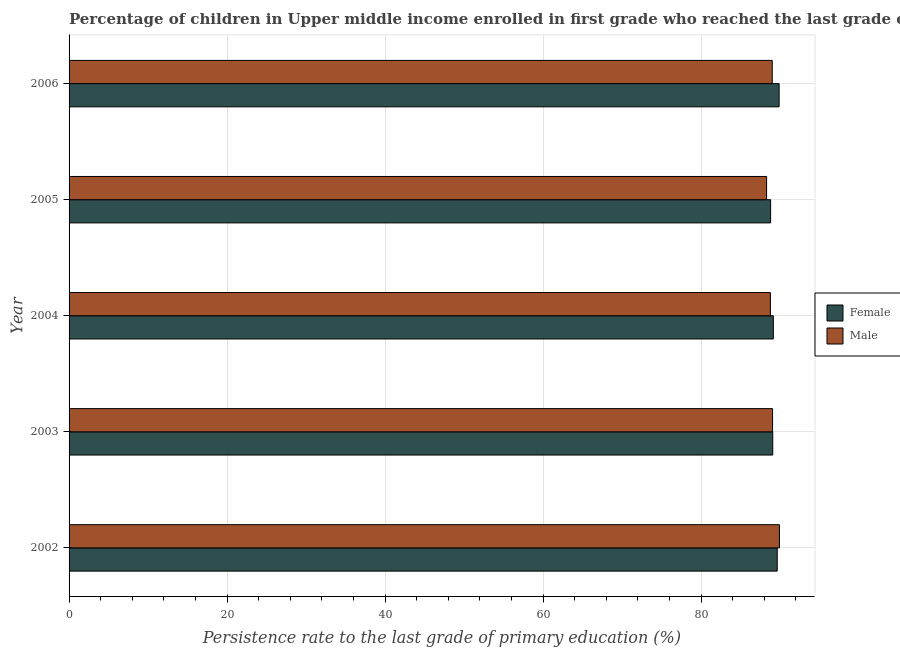How many bars are there on the 2nd tick from the bottom?
Give a very brief answer. 2. What is the label of the 4th group of bars from the top?
Make the answer very short. 2003. What is the persistence rate of male students in 2002?
Give a very brief answer. 89.93. Across all years, what is the maximum persistence rate of male students?
Your answer should be compact. 89.93. Across all years, what is the minimum persistence rate of female students?
Offer a very short reply. 88.81. In which year was the persistence rate of male students maximum?
Ensure brevity in your answer.  2002. What is the total persistence rate of male students in the graph?
Provide a short and direct response. 445.07. What is the difference between the persistence rate of female students in 2004 and that in 2006?
Your answer should be compact. -0.73. What is the difference between the persistence rate of female students in 2003 and the persistence rate of male students in 2006?
Your response must be concise. 0.06. What is the average persistence rate of female students per year?
Your answer should be compact. 89.31. In the year 2002, what is the difference between the persistence rate of female students and persistence rate of male students?
Provide a short and direct response. -0.28. What is the ratio of the persistence rate of female students in 2002 to that in 2004?
Make the answer very short. 1.01. Is the difference between the persistence rate of female students in 2004 and 2006 greater than the difference between the persistence rate of male students in 2004 and 2006?
Offer a terse response. No. What is the difference between the highest and the second highest persistence rate of female students?
Give a very brief answer. 0.24. What is the difference between the highest and the lowest persistence rate of male students?
Provide a succinct answer. 1.63. Does the graph contain any zero values?
Provide a succinct answer. No. How are the legend labels stacked?
Offer a very short reply. Vertical. What is the title of the graph?
Provide a short and direct response. Percentage of children in Upper middle income enrolled in first grade who reached the last grade of primary education. Does "Register a business" appear as one of the legend labels in the graph?
Your response must be concise. No. What is the label or title of the X-axis?
Offer a very short reply. Persistence rate to the last grade of primary education (%). What is the label or title of the Y-axis?
Give a very brief answer. Year. What is the Persistence rate to the last grade of primary education (%) in Female in 2002?
Offer a terse response. 89.64. What is the Persistence rate to the last grade of primary education (%) of Male in 2002?
Your answer should be compact. 89.93. What is the Persistence rate to the last grade of primary education (%) in Female in 2003?
Offer a very short reply. 89.08. What is the Persistence rate to the last grade of primary education (%) in Male in 2003?
Your answer should be compact. 89.05. What is the Persistence rate to the last grade of primary education (%) of Female in 2004?
Your answer should be very brief. 89.15. What is the Persistence rate to the last grade of primary education (%) of Male in 2004?
Provide a short and direct response. 88.78. What is the Persistence rate to the last grade of primary education (%) in Female in 2005?
Make the answer very short. 88.81. What is the Persistence rate to the last grade of primary education (%) of Male in 2005?
Make the answer very short. 88.3. What is the Persistence rate to the last grade of primary education (%) of Female in 2006?
Your answer should be very brief. 89.88. What is the Persistence rate to the last grade of primary education (%) of Male in 2006?
Provide a short and direct response. 89.02. Across all years, what is the maximum Persistence rate to the last grade of primary education (%) in Female?
Make the answer very short. 89.88. Across all years, what is the maximum Persistence rate to the last grade of primary education (%) of Male?
Ensure brevity in your answer.  89.93. Across all years, what is the minimum Persistence rate to the last grade of primary education (%) of Female?
Keep it short and to the point. 88.81. Across all years, what is the minimum Persistence rate to the last grade of primary education (%) of Male?
Ensure brevity in your answer.  88.3. What is the total Persistence rate to the last grade of primary education (%) of Female in the graph?
Offer a terse response. 446.56. What is the total Persistence rate to the last grade of primary education (%) of Male in the graph?
Your answer should be very brief. 445.07. What is the difference between the Persistence rate to the last grade of primary education (%) of Female in 2002 and that in 2003?
Make the answer very short. 0.57. What is the difference between the Persistence rate to the last grade of primary education (%) of Male in 2002 and that in 2003?
Ensure brevity in your answer.  0.87. What is the difference between the Persistence rate to the last grade of primary education (%) in Female in 2002 and that in 2004?
Ensure brevity in your answer.  0.49. What is the difference between the Persistence rate to the last grade of primary education (%) in Male in 2002 and that in 2004?
Keep it short and to the point. 1.15. What is the difference between the Persistence rate to the last grade of primary education (%) of Female in 2002 and that in 2005?
Give a very brief answer. 0.84. What is the difference between the Persistence rate to the last grade of primary education (%) in Male in 2002 and that in 2005?
Keep it short and to the point. 1.63. What is the difference between the Persistence rate to the last grade of primary education (%) in Female in 2002 and that in 2006?
Ensure brevity in your answer.  -0.24. What is the difference between the Persistence rate to the last grade of primary education (%) in Male in 2002 and that in 2006?
Ensure brevity in your answer.  0.91. What is the difference between the Persistence rate to the last grade of primary education (%) in Female in 2003 and that in 2004?
Provide a short and direct response. -0.07. What is the difference between the Persistence rate to the last grade of primary education (%) in Male in 2003 and that in 2004?
Your answer should be compact. 0.27. What is the difference between the Persistence rate to the last grade of primary education (%) of Female in 2003 and that in 2005?
Provide a short and direct response. 0.27. What is the difference between the Persistence rate to the last grade of primary education (%) of Male in 2003 and that in 2005?
Provide a short and direct response. 0.76. What is the difference between the Persistence rate to the last grade of primary education (%) of Female in 2003 and that in 2006?
Provide a succinct answer. -0.81. What is the difference between the Persistence rate to the last grade of primary education (%) of Male in 2003 and that in 2006?
Keep it short and to the point. 0.04. What is the difference between the Persistence rate to the last grade of primary education (%) in Female in 2004 and that in 2005?
Offer a very short reply. 0.34. What is the difference between the Persistence rate to the last grade of primary education (%) in Male in 2004 and that in 2005?
Offer a very short reply. 0.48. What is the difference between the Persistence rate to the last grade of primary education (%) of Female in 2004 and that in 2006?
Provide a succinct answer. -0.73. What is the difference between the Persistence rate to the last grade of primary education (%) of Male in 2004 and that in 2006?
Provide a short and direct response. -0.24. What is the difference between the Persistence rate to the last grade of primary education (%) in Female in 2005 and that in 2006?
Provide a succinct answer. -1.08. What is the difference between the Persistence rate to the last grade of primary education (%) in Male in 2005 and that in 2006?
Ensure brevity in your answer.  -0.72. What is the difference between the Persistence rate to the last grade of primary education (%) of Female in 2002 and the Persistence rate to the last grade of primary education (%) of Male in 2003?
Keep it short and to the point. 0.59. What is the difference between the Persistence rate to the last grade of primary education (%) in Female in 2002 and the Persistence rate to the last grade of primary education (%) in Male in 2004?
Ensure brevity in your answer.  0.86. What is the difference between the Persistence rate to the last grade of primary education (%) of Female in 2002 and the Persistence rate to the last grade of primary education (%) of Male in 2005?
Offer a terse response. 1.35. What is the difference between the Persistence rate to the last grade of primary education (%) of Female in 2002 and the Persistence rate to the last grade of primary education (%) of Male in 2006?
Offer a terse response. 0.63. What is the difference between the Persistence rate to the last grade of primary education (%) of Female in 2003 and the Persistence rate to the last grade of primary education (%) of Male in 2004?
Keep it short and to the point. 0.3. What is the difference between the Persistence rate to the last grade of primary education (%) of Female in 2003 and the Persistence rate to the last grade of primary education (%) of Male in 2005?
Give a very brief answer. 0.78. What is the difference between the Persistence rate to the last grade of primary education (%) in Female in 2003 and the Persistence rate to the last grade of primary education (%) in Male in 2006?
Offer a very short reply. 0.06. What is the difference between the Persistence rate to the last grade of primary education (%) in Female in 2004 and the Persistence rate to the last grade of primary education (%) in Male in 2005?
Keep it short and to the point. 0.85. What is the difference between the Persistence rate to the last grade of primary education (%) in Female in 2004 and the Persistence rate to the last grade of primary education (%) in Male in 2006?
Provide a short and direct response. 0.14. What is the difference between the Persistence rate to the last grade of primary education (%) of Female in 2005 and the Persistence rate to the last grade of primary education (%) of Male in 2006?
Offer a terse response. -0.21. What is the average Persistence rate to the last grade of primary education (%) in Female per year?
Provide a succinct answer. 89.31. What is the average Persistence rate to the last grade of primary education (%) of Male per year?
Your answer should be compact. 89.01. In the year 2002, what is the difference between the Persistence rate to the last grade of primary education (%) of Female and Persistence rate to the last grade of primary education (%) of Male?
Offer a terse response. -0.28. In the year 2003, what is the difference between the Persistence rate to the last grade of primary education (%) in Female and Persistence rate to the last grade of primary education (%) in Male?
Your response must be concise. 0.02. In the year 2004, what is the difference between the Persistence rate to the last grade of primary education (%) of Female and Persistence rate to the last grade of primary education (%) of Male?
Keep it short and to the point. 0.37. In the year 2005, what is the difference between the Persistence rate to the last grade of primary education (%) in Female and Persistence rate to the last grade of primary education (%) in Male?
Ensure brevity in your answer.  0.51. In the year 2006, what is the difference between the Persistence rate to the last grade of primary education (%) of Female and Persistence rate to the last grade of primary education (%) of Male?
Provide a succinct answer. 0.87. What is the ratio of the Persistence rate to the last grade of primary education (%) of Female in 2002 to that in 2003?
Offer a very short reply. 1.01. What is the ratio of the Persistence rate to the last grade of primary education (%) in Male in 2002 to that in 2003?
Provide a short and direct response. 1.01. What is the ratio of the Persistence rate to the last grade of primary education (%) in Male in 2002 to that in 2004?
Your answer should be very brief. 1.01. What is the ratio of the Persistence rate to the last grade of primary education (%) of Female in 2002 to that in 2005?
Provide a succinct answer. 1.01. What is the ratio of the Persistence rate to the last grade of primary education (%) in Male in 2002 to that in 2005?
Offer a very short reply. 1.02. What is the ratio of the Persistence rate to the last grade of primary education (%) of Female in 2002 to that in 2006?
Give a very brief answer. 1. What is the ratio of the Persistence rate to the last grade of primary education (%) of Male in 2002 to that in 2006?
Your answer should be compact. 1.01. What is the ratio of the Persistence rate to the last grade of primary education (%) in Female in 2003 to that in 2004?
Provide a succinct answer. 1. What is the ratio of the Persistence rate to the last grade of primary education (%) in Female in 2003 to that in 2005?
Offer a terse response. 1. What is the ratio of the Persistence rate to the last grade of primary education (%) in Male in 2003 to that in 2005?
Your answer should be very brief. 1.01. What is the ratio of the Persistence rate to the last grade of primary education (%) in Female in 2004 to that in 2005?
Provide a succinct answer. 1. What is the ratio of the Persistence rate to the last grade of primary education (%) of Male in 2004 to that in 2005?
Provide a short and direct response. 1.01. What is the difference between the highest and the second highest Persistence rate to the last grade of primary education (%) of Female?
Your response must be concise. 0.24. What is the difference between the highest and the second highest Persistence rate to the last grade of primary education (%) in Male?
Your response must be concise. 0.87. What is the difference between the highest and the lowest Persistence rate to the last grade of primary education (%) of Female?
Your answer should be very brief. 1.08. What is the difference between the highest and the lowest Persistence rate to the last grade of primary education (%) of Male?
Provide a short and direct response. 1.63. 